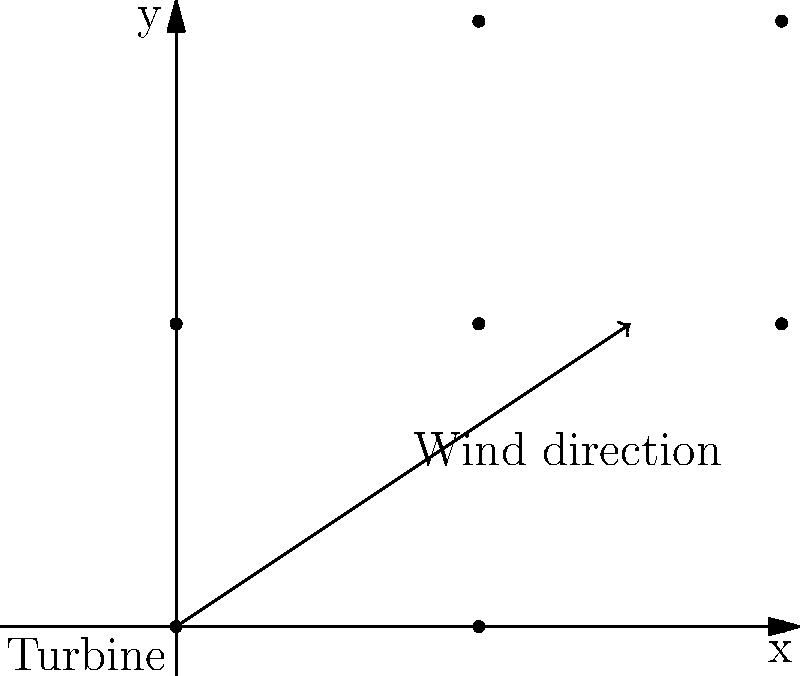A wind farm consists of 9 turbines arranged in a 3x3 grid, with each turbine spaced 200 meters apart. The wind is blowing at a 30-degree angle to the horizontal, as shown in the diagram. If each turbine has a rated power output of 2 MW when the wind is directly perpendicular to its blades, estimate the total power output of the wind farm, assuming the power output is proportional to the cosine of the angle between the wind direction and the perpendicular to the turbine blades. To solve this problem, we'll follow these steps:

1) First, we need to determine the angle between the wind direction and the perpendicular to the turbine blades. The turbines are assumed to be facing the y-axis, so the perpendicular to their blades is along the x-axis. The wind is at a 30-degree angle to the horizontal (x-axis).

   Angle between wind and turbine perpendicular = 90° - 30° = 60°

2) The power output is proportional to the cosine of this angle:

   Power factor = cos(60°) ≈ 0.5

3) Each turbine has a rated power output of 2 MW when the wind is perpendicular. With the given wind direction, each turbine will produce:

   Actual power per turbine = 2 MW × 0.5 = 1 MW

4) There are 9 turbines in total, so the total power output will be:

   Total power output = 9 × 1 MW = 9 MW

Therefore, the estimated total power output of the wind farm under these conditions is 9 MW.
Answer: 9 MW 